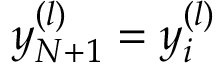<formula> <loc_0><loc_0><loc_500><loc_500>y _ { N + 1 } ^ { ( l ) } = y _ { i } ^ { ( l ) }</formula> 